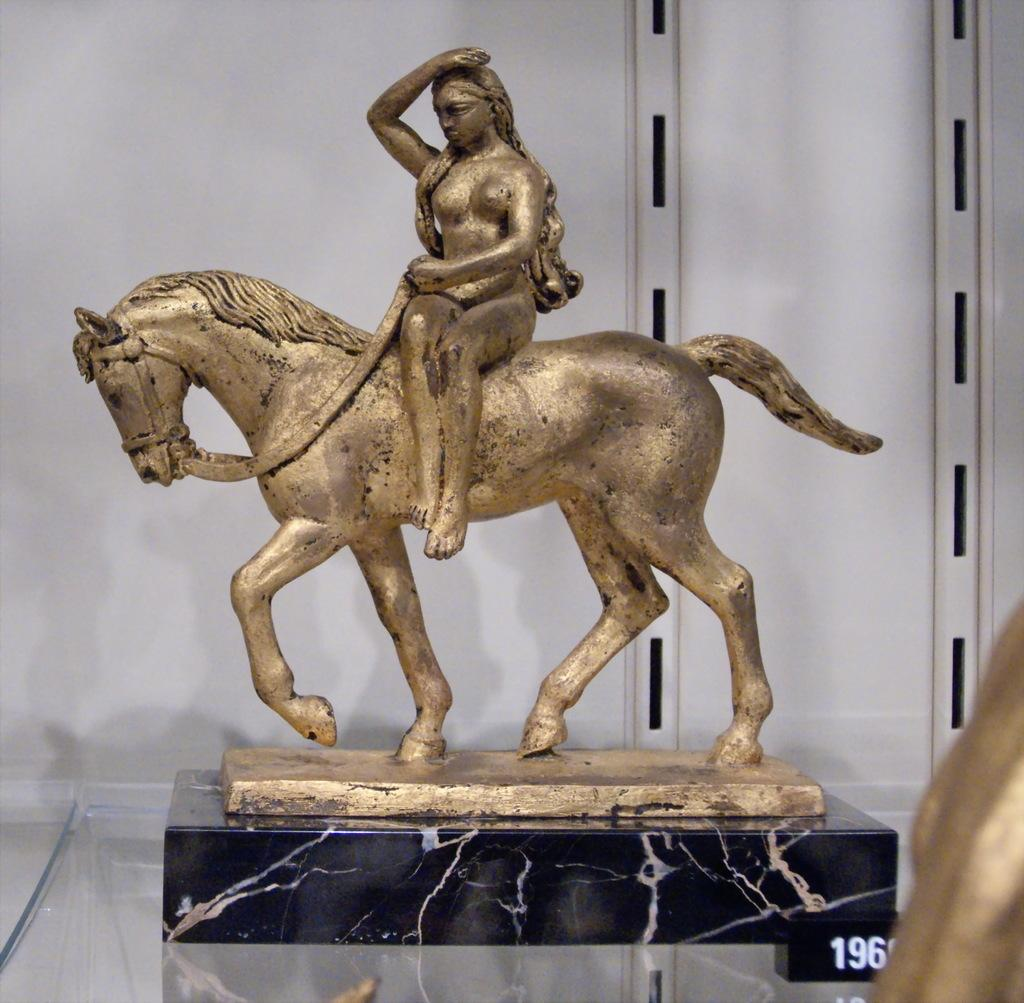What is the main subject of the image? The main subject of the image is a statue of a person. How is the person depicted in the statue? The person is depicted as sitting on a horse. What material is the statue placed on? The statue is placed on a glass surface. What type of grip does the person have on the horse's reins in the image? There are no reins visible in the image, and the person's grip cannot be determined. 